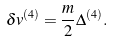Convert formula to latex. <formula><loc_0><loc_0><loc_500><loc_500>\delta v ^ { ( 4 ) } = \frac { m } { 2 } \Delta ^ { ( 4 ) } .</formula> 